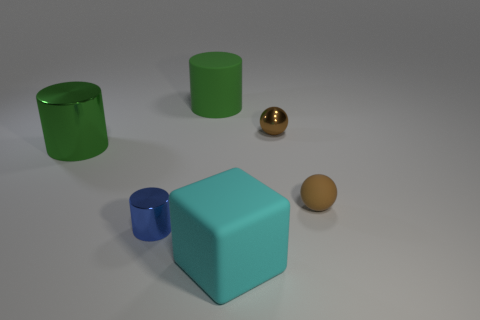Does the small cylinder have the same material as the green object that is behind the small brown shiny ball?
Provide a short and direct response. No. What number of cylinders are left of the big matte object that is in front of the brown thing behind the brown rubber sphere?
Your answer should be very brief. 3. What number of green things are large matte cylinders or rubber objects?
Give a very brief answer. 1. The big rubber object that is right of the green rubber thing has what shape?
Provide a short and direct response. Cube. There is a rubber block that is the same size as the green metallic cylinder; what is its color?
Provide a succinct answer. Cyan. Do the green metallic object and the small thing on the left side of the block have the same shape?
Offer a very short reply. Yes. What is the tiny object that is on the left side of the matte thing that is in front of the metallic cylinder that is in front of the small matte ball made of?
Your response must be concise. Metal. How many small things are blue shiny cylinders or brown things?
Your answer should be very brief. 3. There is a green thing that is left of the tiny blue cylinder; is it the same shape as the tiny rubber object?
Your answer should be compact. No. There is a matte object that is the same shape as the small blue metallic thing; what is its color?
Provide a short and direct response. Green. 